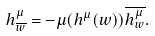<formula> <loc_0><loc_0><loc_500><loc_500>h ^ { \mu } _ { \overline { w } } = - \mu ( h ^ { \mu } ( w ) ) \overline { h ^ { \mu } _ { w } } .</formula> 